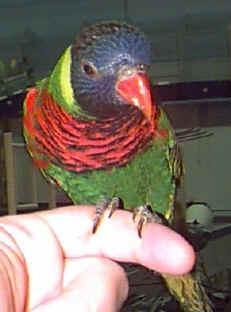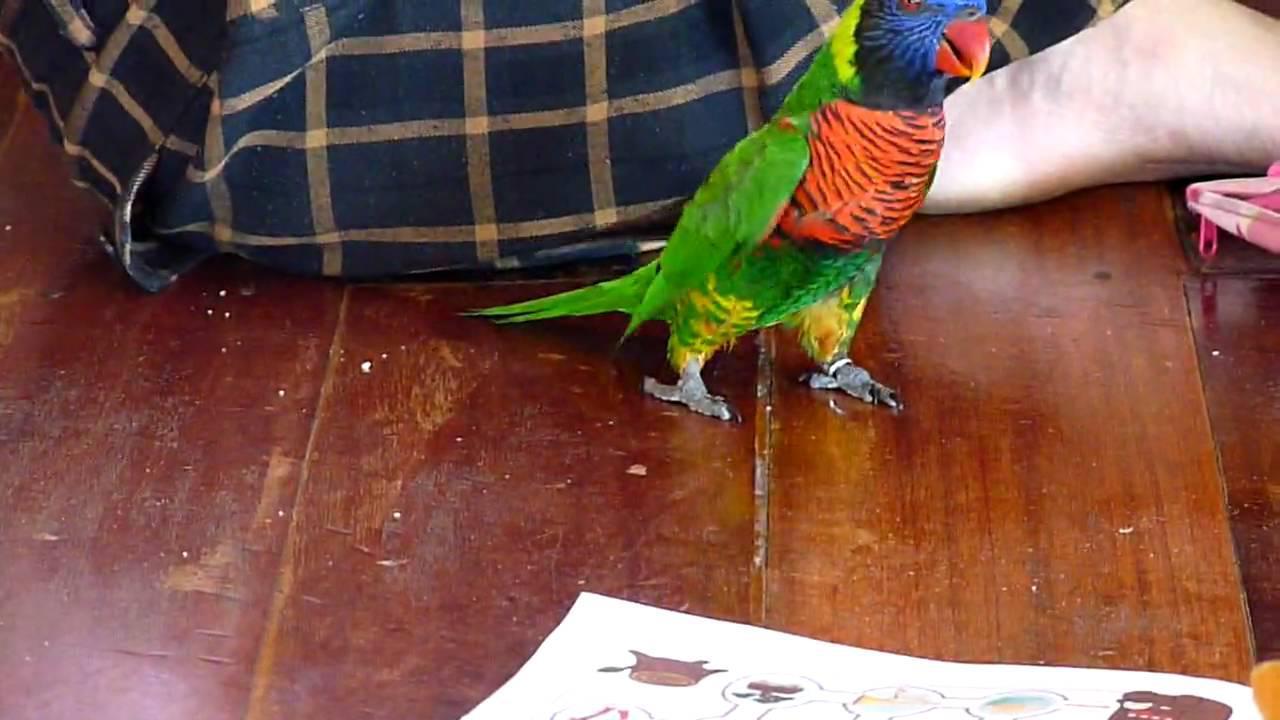The first image is the image on the left, the second image is the image on the right. Evaluate the accuracy of this statement regarding the images: "The left image shows exactly one parrot, and it is perched on a wooden limb.". Is it true? Answer yes or no. No. The first image is the image on the left, the second image is the image on the right. Analyze the images presented: Is the assertion "Exactly two parrots are sitting on tree branches, both of them having at least some green on their bodies, but only one with a blue head." valid? Answer yes or no. No. 